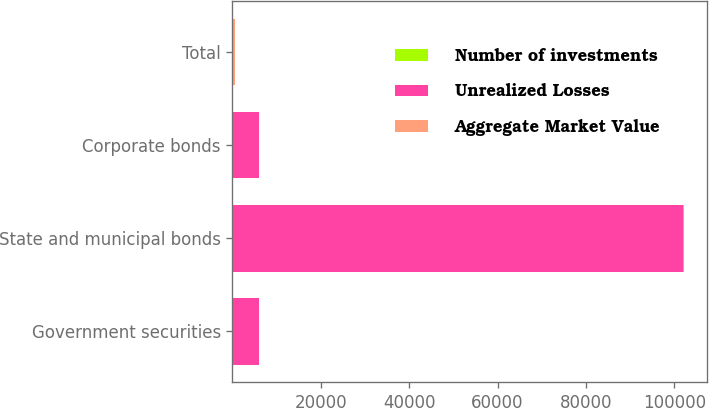<chart> <loc_0><loc_0><loc_500><loc_500><stacked_bar_chart><ecel><fcel>Government securities<fcel>State and municipal bonds<fcel>Corporate bonds<fcel>Total<nl><fcel>Number of investments<fcel>1<fcel>50<fcel>2<fcel>53<nl><fcel>Unrealized Losses<fcel>5954<fcel>101851<fcel>6034<fcel>61<nl><fcel>Aggregate Market Value<fcel>4<fcel>396<fcel>61<fcel>461<nl></chart> 